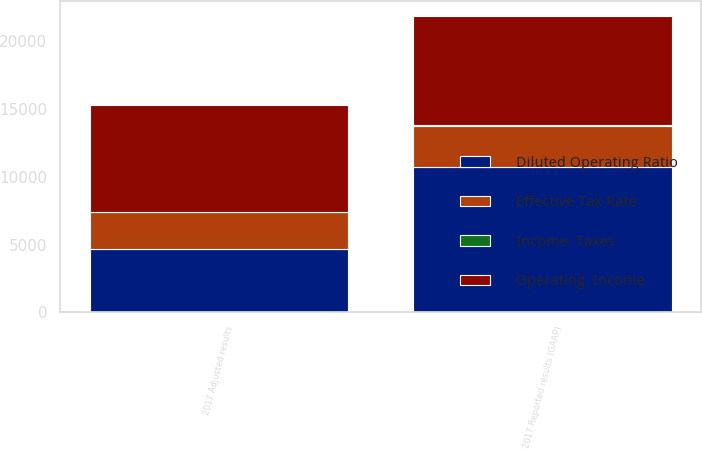<chart> <loc_0><loc_0><loc_500><loc_500><stacked_bar_chart><ecel><fcel>2017 Reported results (GAAP)<fcel>2017 Adjusted results<nl><fcel>Operating  Income<fcel>8106<fcel>7894<nl><fcel>Effective Tax Rate<fcel>3080<fcel>2782<nl><fcel>Diluted Operating Ratio<fcel>10712<fcel>4638<nl><fcel>Income  Taxes<fcel>13.36<fcel>5.79<nl></chart> 